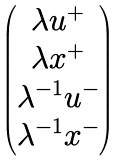Convert formula to latex. <formula><loc_0><loc_0><loc_500><loc_500>\begin{pmatrix} \lambda u ^ { + } \\ \lambda x ^ { + } \\ \lambda ^ { - 1 } u ^ { - } \\ \lambda ^ { - 1 } x ^ { - } \end{pmatrix}</formula> 